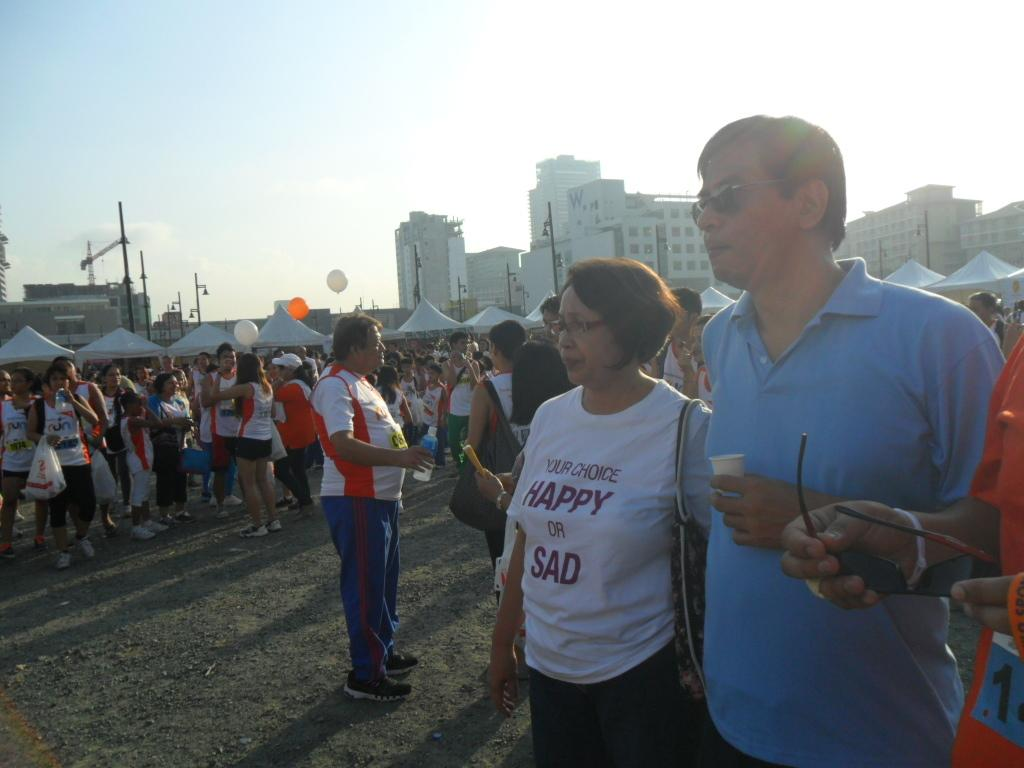What is happening in the image that has attracted a large crowd? The event suggests a gathering of people, but the specific event is not mentioned in the facts. What can be observed about the surrounding environment of the crowd? There are many big buildings surrounding the area. What is visible in the background of the image? The sky is visible in the background. What type of punishment is being handed out to the banana in the image? There is no banana present in the image, and therefore no punishment can be observed. 